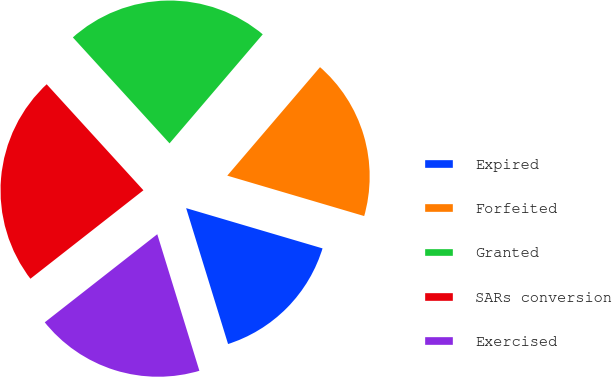Convert chart. <chart><loc_0><loc_0><loc_500><loc_500><pie_chart><fcel>Expired<fcel>Forfeited<fcel>Granted<fcel>SARs conversion<fcel>Exercised<nl><fcel>15.67%<fcel>18.31%<fcel>23.03%<fcel>23.8%<fcel>19.19%<nl></chart> 